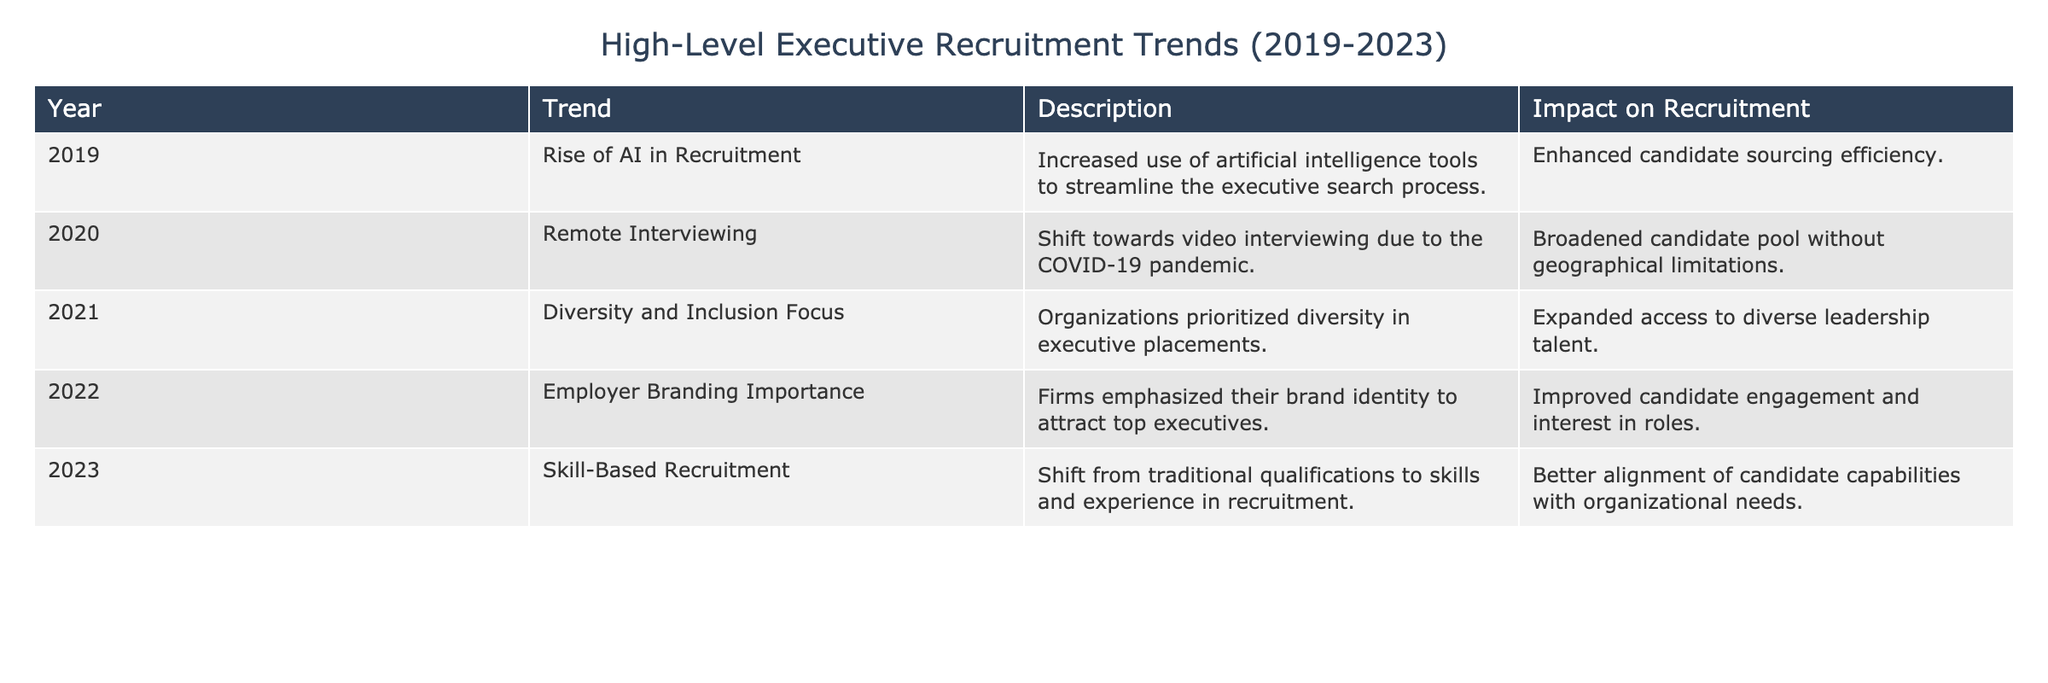What was the trend in 2020 regarding recruitment? The table shows that in 2020, the trend was "Remote Interviewing," which describes a shift towards video interviewing due to the COVID-19 pandemic.
Answer: Remote Interviewing How many trends focused specifically on enhancing diversity in executive placements? According to the table, there is one trend explicitly focused on diversity, which is the "Diversity and Inclusion Focus" in 2021.
Answer: One trend Was there an emphasis on employer branding before 2022? The table indicates that the focus on "Employer Branding Importance" started in 2022, so there was no emphasis on this aspect in the previous years.
Answer: No What was the impact of the shift towards skill-based recruitment in 2023? The table states that the impact of skill-based recruitment was better alignment of candidate capabilities with organizational needs, which is a significant improvement.
Answer: Better alignment of capabilities Can we conclude that every trend mentioned in the table had a positive impact on recruitment? Yes, all the trends listed, from increased efficiency to improved candidate engagement, suggest that each trend had a positive impact on recruitment as described in the "Impact on Recruitment" column.
Answer: Yes Which year saw the first mention of the importance of diversity in recruitment trends? The table reveals that diversity was first emphasized in 2021 with the "Diversity and Inclusion Focus" trend.
Answer: 2021 What are the trends over the years from 2019 to 2023, and how might they reflect a shift in recruitment strategies? Each year shows a progression from AI tools, remote interviews, diversity focus, branding importance, to skill-based recruitment, reflecting a shift towards more modern, efficient, and inclusive strategies.
Answer: Progressive shift in strategies How did the COVID-19 pandemic influence recruitment trends in 2020? The table notes that the pandemic prompted a shift towards video interviewing, which broadened the candidate pool without geographic limitations.
Answer: Broadened candidate pool Was the trend of diversity and inclusion common across all five years listed in the table? No, the focus on diversity and inclusion was specifically noted only in 2021, indicating it was not a trend in every year.
Answer: No 